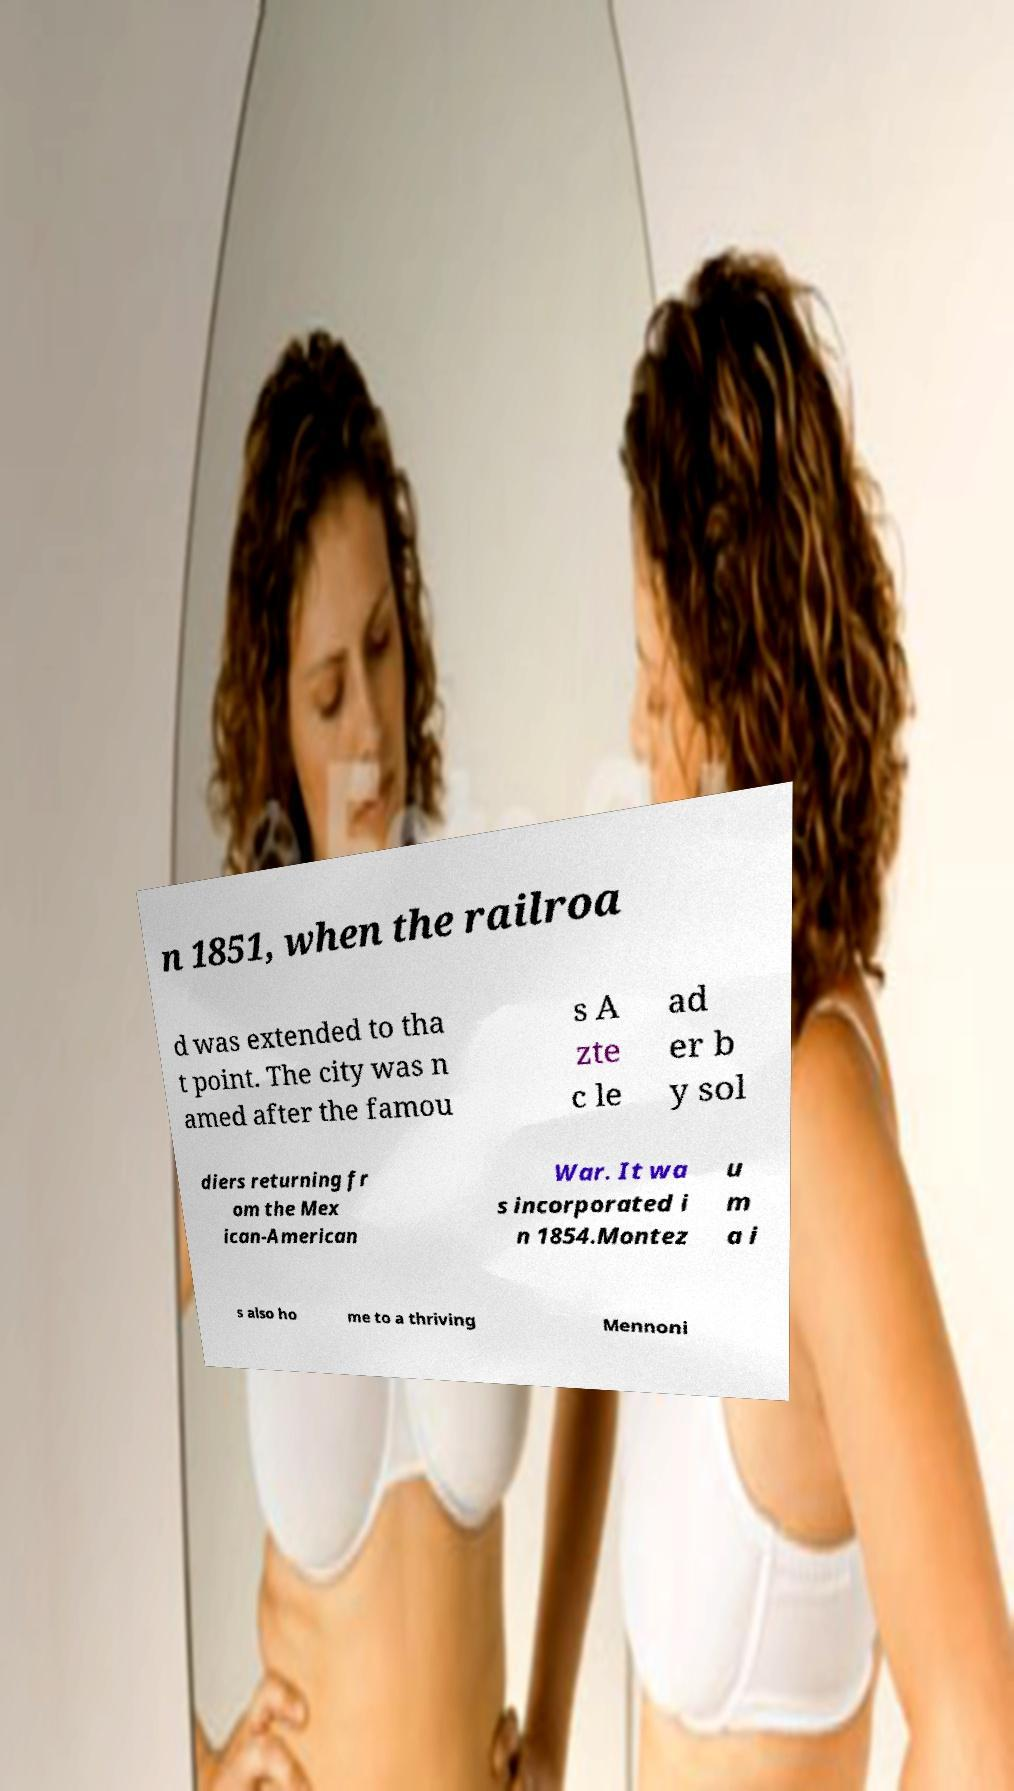What messages or text are displayed in this image? I need them in a readable, typed format. n 1851, when the railroa d was extended to tha t point. The city was n amed after the famou s A zte c le ad er b y sol diers returning fr om the Mex ican-American War. It wa s incorporated i n 1854.Montez u m a i s also ho me to a thriving Mennoni 